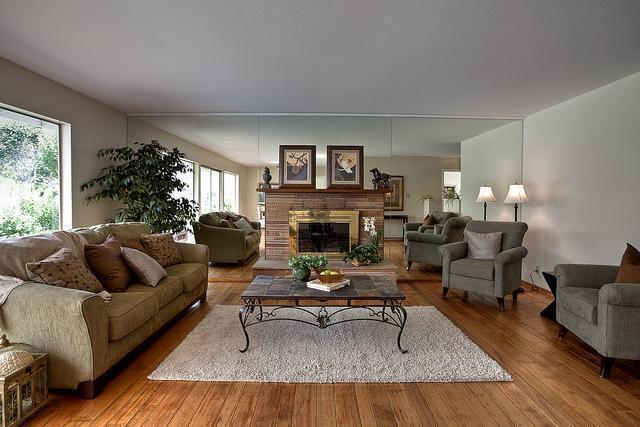What is the gold framed area against the back wall used to hold?
Select the accurate response from the four choices given to answer the question.
Options: Fire, water, pictures, books. Fire. 